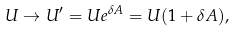<formula> <loc_0><loc_0><loc_500><loc_500>U \rightarrow U ^ { \prime } = U e ^ { \delta A } = U ( 1 + \delta A ) ,</formula> 